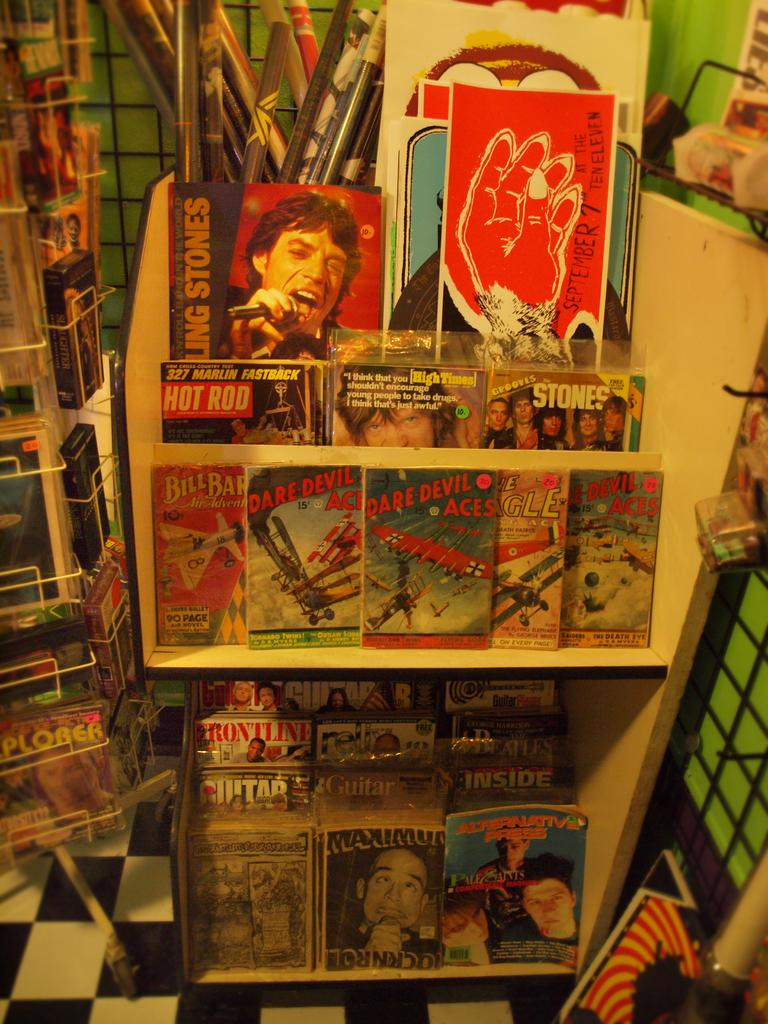Provide a one-sentence caption for the provided image. A display with magazines like Frontline and comics like Daredevil Aces. 